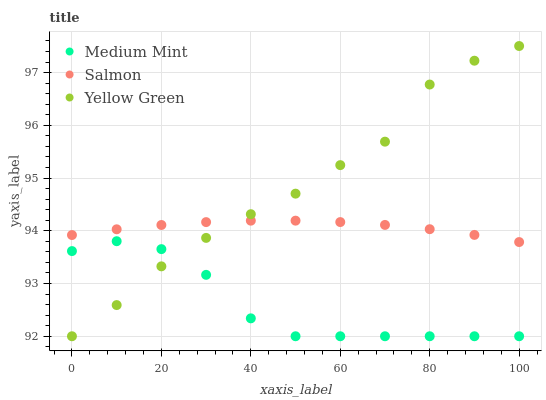Does Medium Mint have the minimum area under the curve?
Answer yes or no. Yes. Does Yellow Green have the maximum area under the curve?
Answer yes or no. Yes. Does Salmon have the minimum area under the curve?
Answer yes or no. No. Does Salmon have the maximum area under the curve?
Answer yes or no. No. Is Salmon the smoothest?
Answer yes or no. Yes. Is Yellow Green the roughest?
Answer yes or no. Yes. Is Yellow Green the smoothest?
Answer yes or no. No. Is Salmon the roughest?
Answer yes or no. No. Does Medium Mint have the lowest value?
Answer yes or no. Yes. Does Salmon have the lowest value?
Answer yes or no. No. Does Yellow Green have the highest value?
Answer yes or no. Yes. Does Salmon have the highest value?
Answer yes or no. No. Is Medium Mint less than Salmon?
Answer yes or no. Yes. Is Salmon greater than Medium Mint?
Answer yes or no. Yes. Does Medium Mint intersect Yellow Green?
Answer yes or no. Yes. Is Medium Mint less than Yellow Green?
Answer yes or no. No. Is Medium Mint greater than Yellow Green?
Answer yes or no. No. Does Medium Mint intersect Salmon?
Answer yes or no. No. 